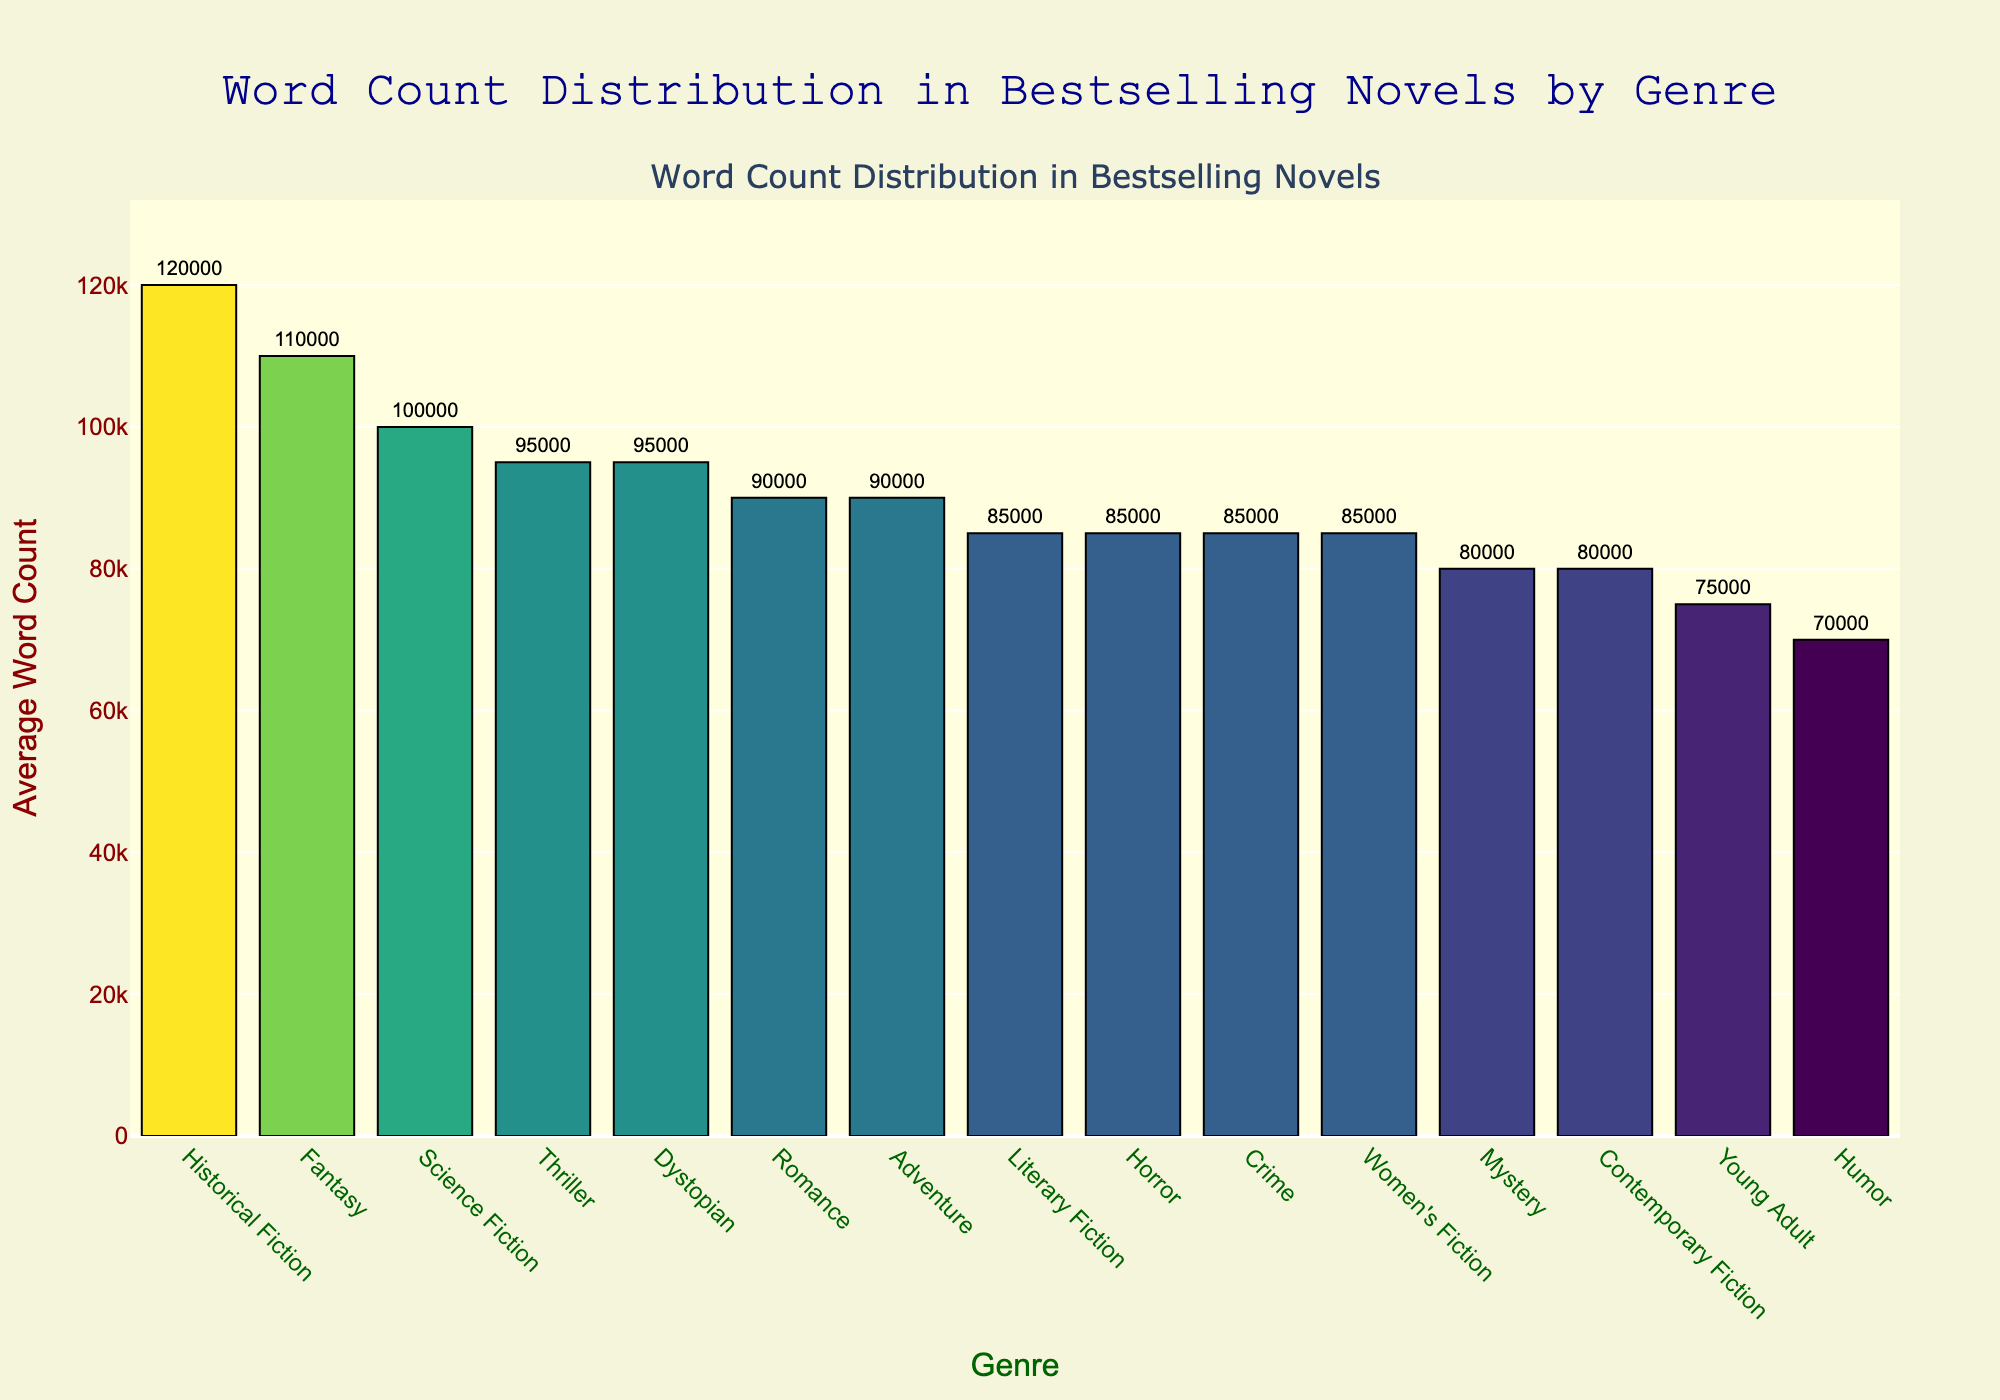What genre has the highest average word count? The bar representing Historical Fiction is the tallest, indicating it has the highest average word count at 120,000 words.
Answer: Historical Fiction Which two genres have an equal average word count? The bars for Literary Fiction, Horror, Crime, and Women's Fiction are of equal height, each showing an average word count of 85,000 words.
Answer: Literary Fiction, Horror, Crime, Women's Fiction What is the difference in average word count between Thriller and Humor genres? Locate the bars for Thriller and Humor. Thriller has 95,000 words, and Humor has 70,000 words. The difference is 95,000 - 70,000 = 25,000 words.
Answer: 25,000 words Which genre has a higher average word count: Fantasy or Romance? Compare the heights of the bars for Fantasy and Romance. Fantasy is higher with 110,000 words, while Romance has 90,000 words.
Answer: Fantasy How much greater is the average word count for Science Fiction compared to Mystery? Science Fiction's bar shows 100,000 words, and Mystery's shows 80,000 words. The difference is 100,000 - 80,000 = 20,000 words.
Answer: 20,000 words What is the combined average word count of Adventure, Young Adult, and Contemporary Fiction genres? Add the word counts of Adventure (90,000), Young Adult (75,000), and Contemporary Fiction (80,000). The sum is 90,000 + 75,000 + 80,000 = 245,000 words.
Answer: 245,000 words Which genre has an average word count closer to 80,000: Horror or Contemporary Fiction? Both Horror and Contemporary Fiction have average word counts displayed. Horror has 85,000 words and Contemporary Fiction has 80,000 words. Contemporary Fiction matches exactly, while Horror is 5,000 words off.
Answer: Contemporary Fiction Are there more genres with an average word count above 90,000 or below 90,000? Count the genres with word counts above 90,000 (Thriller, Science Fiction, Fantasy, Historical Fiction, Dystopian) and those below 90,000 (Romance, Mystery, Young Adult, Humor, Literary Fiction, Horror, Contemporary Fiction, Crime, Women's Fiction). There are 5 genres above and 9 genres below.
Answer: Below 90,000 What is the total average word count for Romance and Crime genres combined? Add the average word counts for Romance (90,000) and Crime (85,000): 90,000 + 85,000 = 175,000 words.
Answer: 175,000 words Which genre has a shorter average word count: Young Adult or Humor? Compare the heights of the bars for Young Adult and Humor. Humor's bar is shorter with 70,000 words, while Young Adult has 75,000 words.
Answer: Humor 